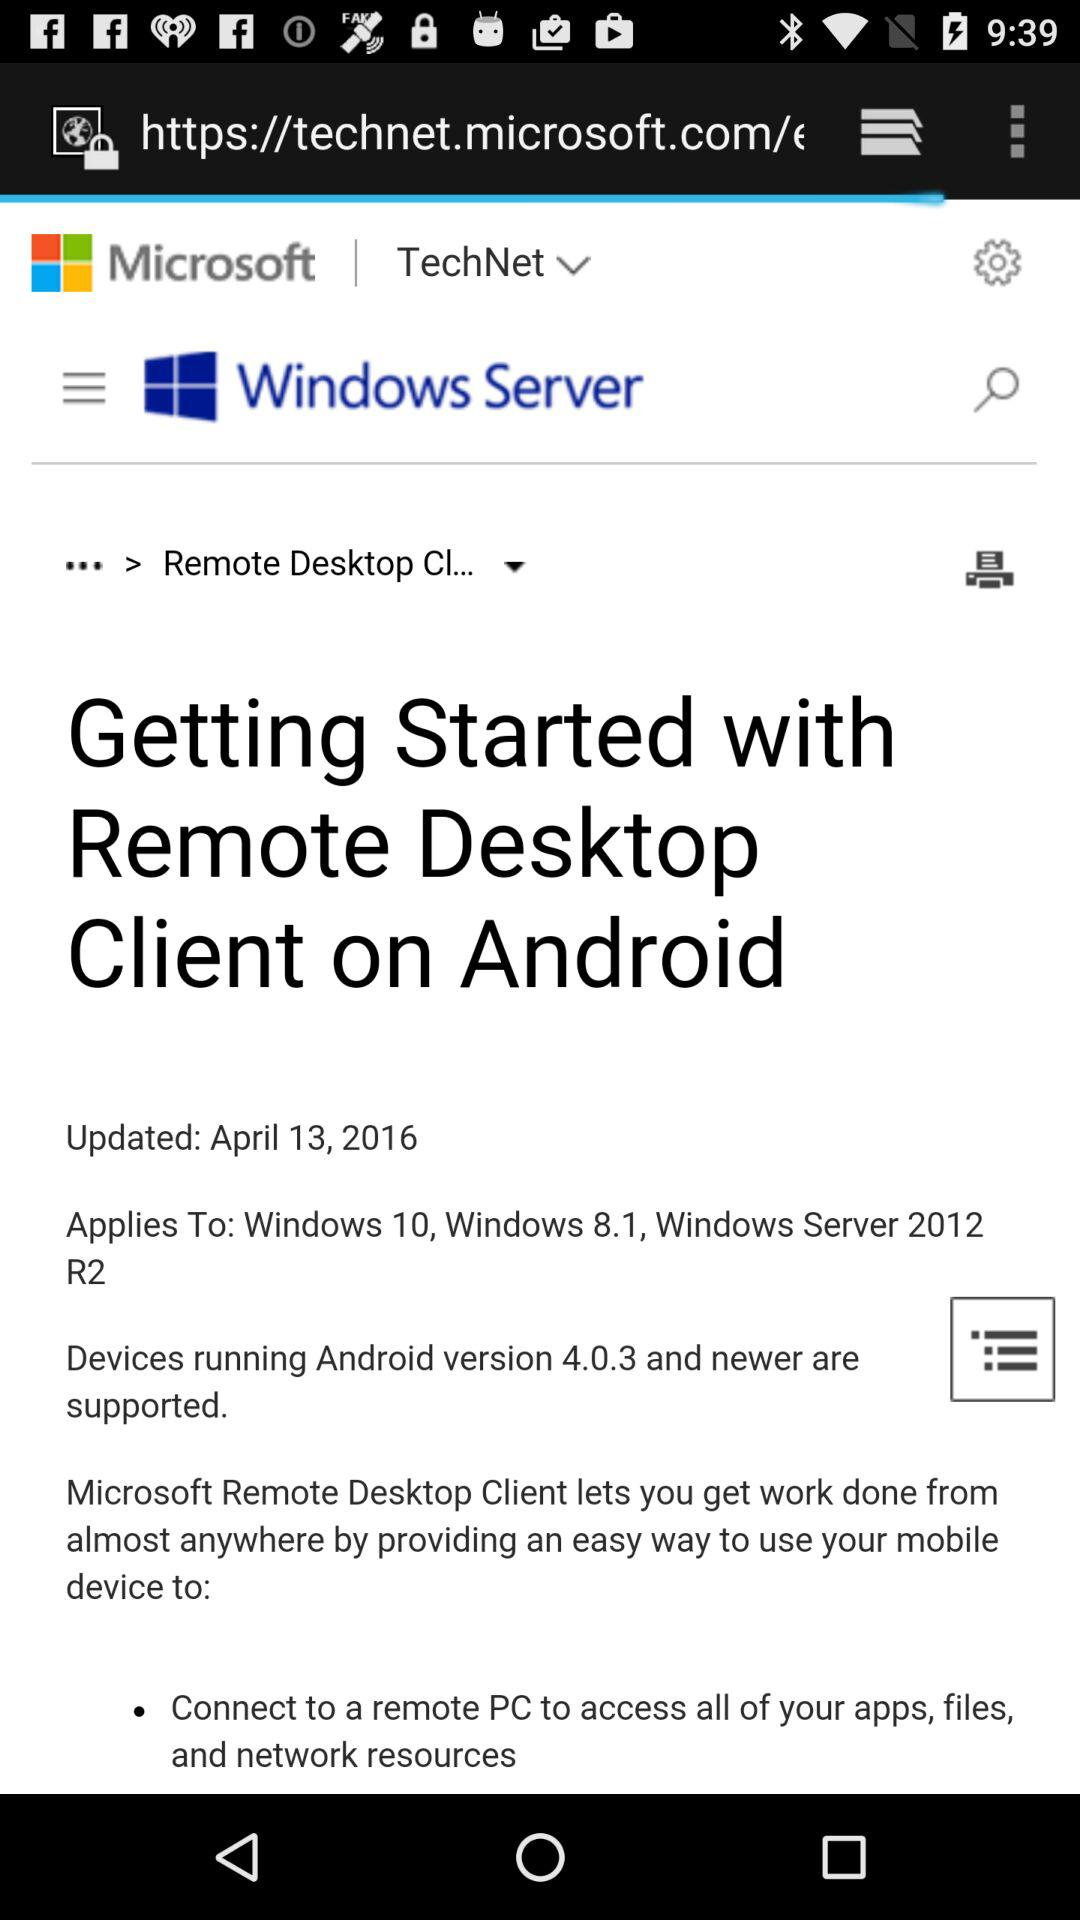What is the date of updation of the article? The date of updation is April 13, 2016. 